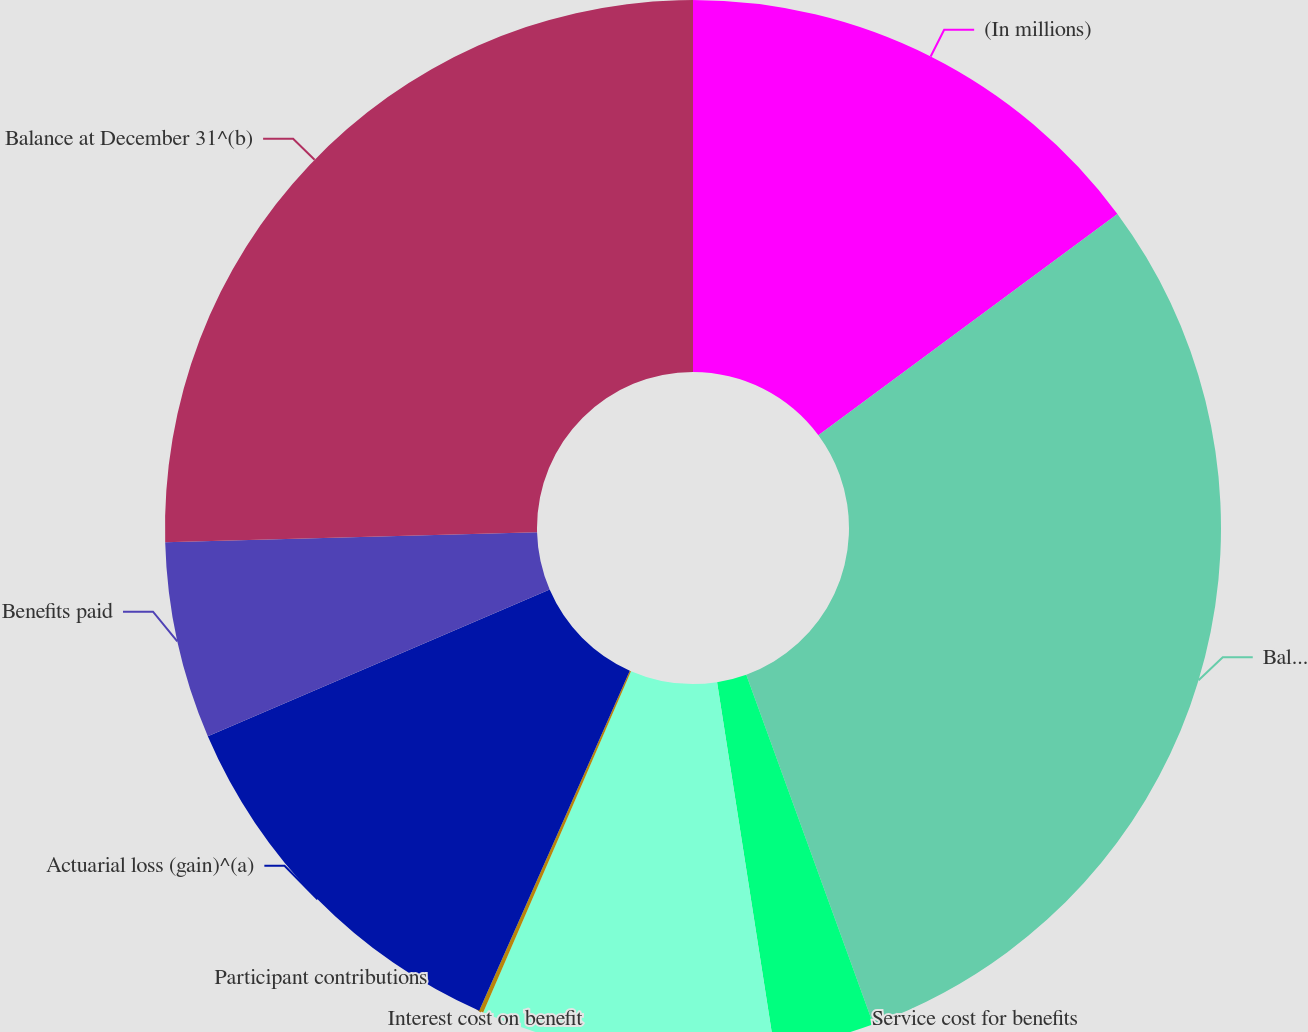<chart> <loc_0><loc_0><loc_500><loc_500><pie_chart><fcel>(In millions)<fcel>Balance at January 1<fcel>Service cost for benefits<fcel>Interest cost on benefit<fcel>Participant contributions<fcel>Actuarial loss (gain)^(a)<fcel>Benefits paid<fcel>Balance at December 31^(b)<nl><fcel>14.86%<fcel>29.59%<fcel>3.08%<fcel>8.97%<fcel>0.13%<fcel>11.91%<fcel>6.02%<fcel>25.43%<nl></chart> 